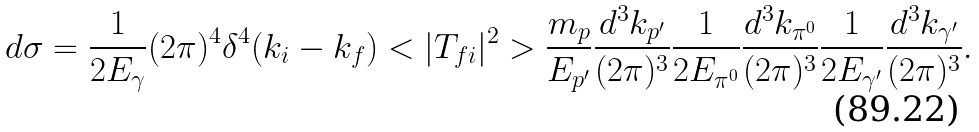<formula> <loc_0><loc_0><loc_500><loc_500>d \sigma = \frac { 1 } { 2 E _ { \gamma } } ( 2 \pi ) ^ { 4 } \delta ^ { 4 } ( k _ { i } - k _ { f } ) < | T _ { f i } | ^ { 2 } > \frac { m _ { p } } { E _ { p ^ { \prime } } } \frac { d ^ { 3 } { k } _ { p ^ { \prime } } } { ( 2 \pi ) ^ { 3 } } \frac { 1 } { 2 E _ { \pi ^ { 0 } } } \frac { d ^ { 3 } { k } _ { \pi ^ { 0 } } } { ( 2 \pi ) ^ { 3 } } \frac { 1 } { 2 E _ { \gamma ^ { \prime } } } \frac { d ^ { 3 } { k } _ { \gamma ^ { \prime } } } { ( 2 \pi ) ^ { 3 } } .</formula> 